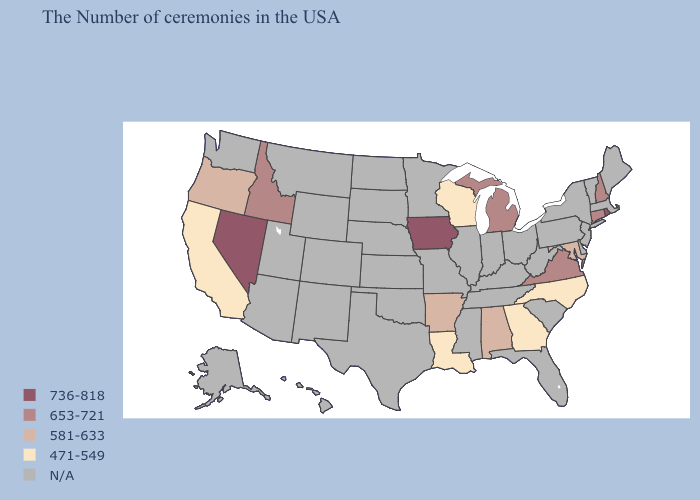Which states have the highest value in the USA?
Be succinct. Rhode Island, Iowa, Nevada. Does Iowa have the lowest value in the USA?
Short answer required. No. Name the states that have a value in the range N/A?
Short answer required. Maine, Massachusetts, Vermont, New York, New Jersey, Delaware, Pennsylvania, South Carolina, West Virginia, Ohio, Florida, Kentucky, Indiana, Tennessee, Illinois, Mississippi, Missouri, Minnesota, Kansas, Nebraska, Oklahoma, Texas, South Dakota, North Dakota, Wyoming, Colorado, New Mexico, Utah, Montana, Arizona, Washington, Alaska, Hawaii. Which states have the highest value in the USA?
Give a very brief answer. Rhode Island, Iowa, Nevada. What is the value of Mississippi?
Be succinct. N/A. What is the highest value in states that border Washington?
Keep it brief. 653-721. What is the value of Indiana?
Concise answer only. N/A. Name the states that have a value in the range N/A?
Be succinct. Maine, Massachusetts, Vermont, New York, New Jersey, Delaware, Pennsylvania, South Carolina, West Virginia, Ohio, Florida, Kentucky, Indiana, Tennessee, Illinois, Mississippi, Missouri, Minnesota, Kansas, Nebraska, Oklahoma, Texas, South Dakota, North Dakota, Wyoming, Colorado, New Mexico, Utah, Montana, Arizona, Washington, Alaska, Hawaii. Among the states that border Connecticut , which have the highest value?
Short answer required. Rhode Island. Does the first symbol in the legend represent the smallest category?
Be succinct. No. Does the map have missing data?
Short answer required. Yes. 